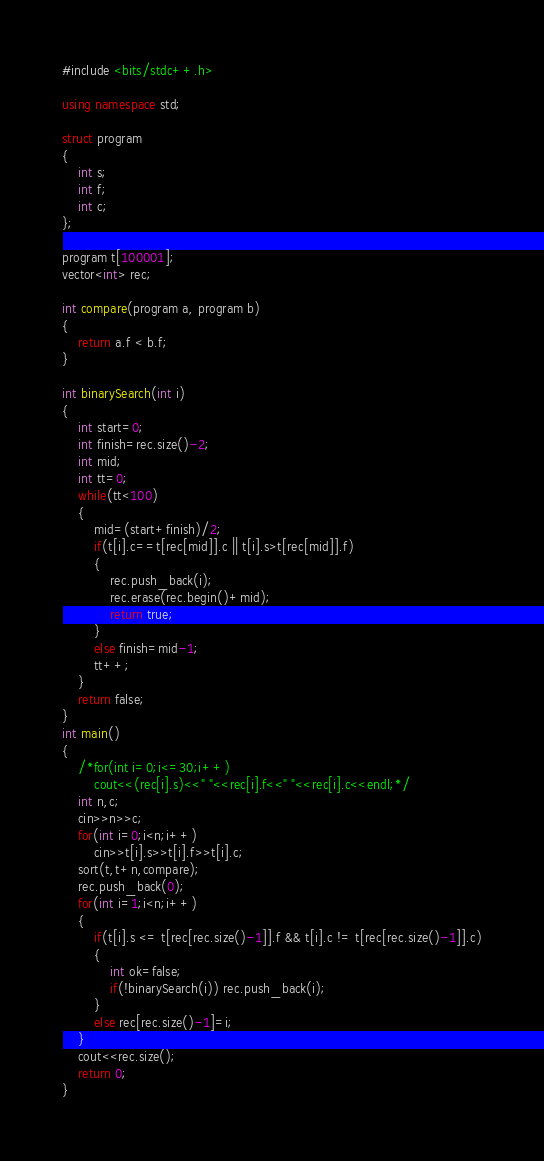Convert code to text. <code><loc_0><loc_0><loc_500><loc_500><_C++_>#include <bits/stdc++.h>

using namespace std;

struct program
{
    int s;
    int f;
    int c;
};

program t[100001];
vector<int> rec;

int compare(program a, program b)
{
    return a.f < b.f;
}

int binarySearch(int i)
{
    int start=0;
    int finish=rec.size()-2;
    int mid;
    int tt=0;
    while(tt<100)
    {
        mid=(start+finish)/2;
        if(t[i].c==t[rec[mid]].c || t[i].s>t[rec[mid]].f)
        {
            rec.push_back(i);
            rec.erase(rec.begin()+mid);
            return true;
        }
        else finish=mid-1;
        tt++;
    }
    return false;
}
int main()
{
    /*for(int i=0;i<=30;i++)
        cout<<(rec[i].s)<<" "<<rec[i].f<<" "<<rec[i].c<<endl;*/
    int n,c;
    cin>>n>>c;
    for(int i=0;i<n;i++)
        cin>>t[i].s>>t[i].f>>t[i].c;
    sort(t,t+n,compare);
    rec.push_back(0);
    for(int i=1;i<n;i++)
    {
        if(t[i].s <= t[rec[rec.size()-1]].f && t[i].c != t[rec[rec.size()-1]].c)
        {
            int ok=false;
            if(!binarySearch(i)) rec.push_back(i);
        }
        else rec[rec.size()-1]=i;
    }
    cout<<rec.size();
    return 0;
}
</code> 